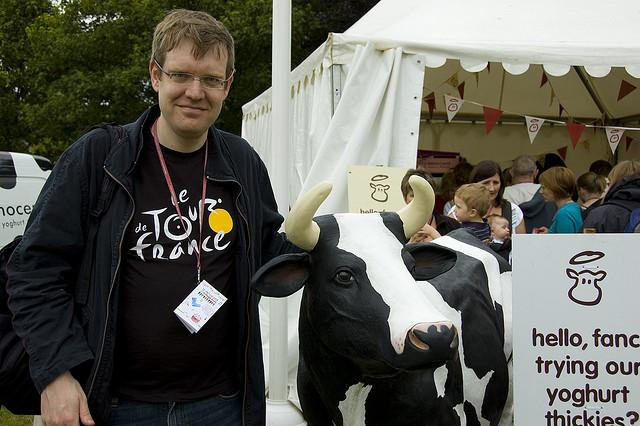What type of industry is being represented? dairy 